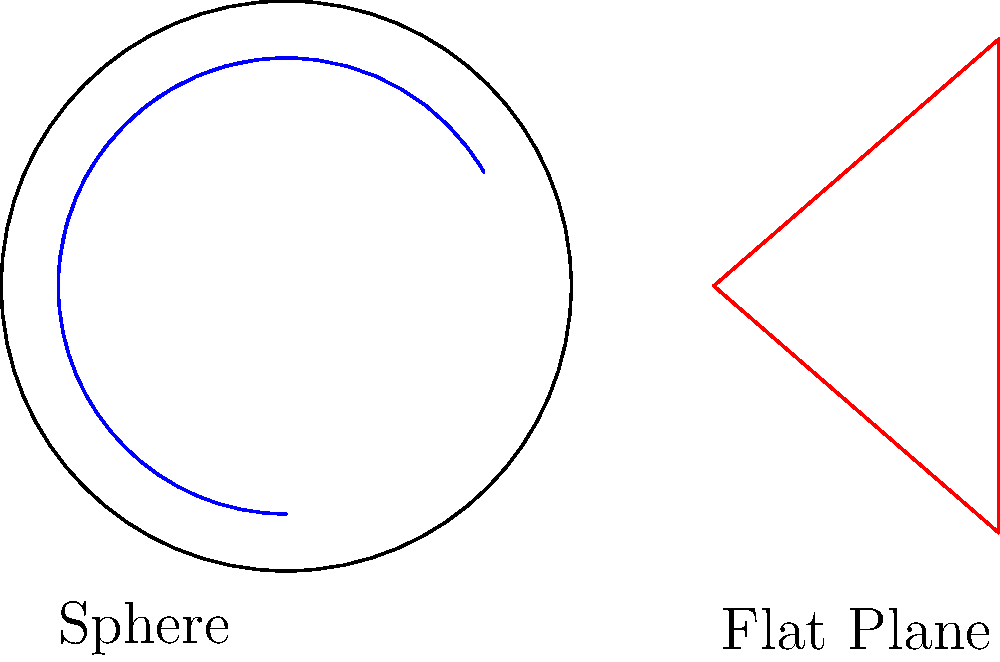In the context of non-Euclidean geometry, consider a triangle drawn on the surface of a sphere (blue) and a triangle drawn on a flat plane (red). How does the sum of the interior angles of the spherical triangle compare to that of the flat triangle? Explain the significance of this difference in relation to the curvature of space and its potential implications for our understanding of social justice issues. To understand the difference between spherical and flat triangles:

1. Flat plane triangle:
   - In Euclidean geometry, the sum of interior angles is always 180°.
   - This is represented by the formula: $\sum \text{angles} = 180°$

2. Spherical triangle:
   - On a sphere, the sum of interior angles is always greater than 180°.
   - The formula for a spherical triangle is: $\sum \text{angles} = 180° + A$
   - Where $A$ is the area of the triangle on the sphere's surface.

3. Curvature and angle sum:
   - The excess angle ($A$) is directly related to the curvature of the surface.
   - Positive curvature (sphere) results in angle sum > 180°.
   - Zero curvature (flat plane) results in angle sum = 180°.
   - Negative curvature (hyperbolic surface) results in angle sum < 180°.

4. Implications for social justice:
   - This geometric concept can be metaphorically applied to social issues:
     a. Curved spaces (spherical triangles) represent complex, interconnected social systems.
     b. Flat spaces (Euclidean triangles) represent simplified, linear approaches to social issues.
   - Understanding the "curvature" of social problems can lead to more nuanced solutions.
   - The Santa Cruz Eleven case, for example, might require a "non-Euclidean" approach to justice, considering the complexities and interconnections of social activism, property rights, and law enforcement.

5. Conclusion:
   The sum of angles in a spherical triangle is always greater than 180°, while it's exactly 180° for a flat triangle. This difference highlights the importance of context and perspective in both geometry and social justice issues.
Answer: Spherical triangle: $\sum \text{angles} > 180°$; Flat triangle: $\sum \text{angles} = 180°$ 